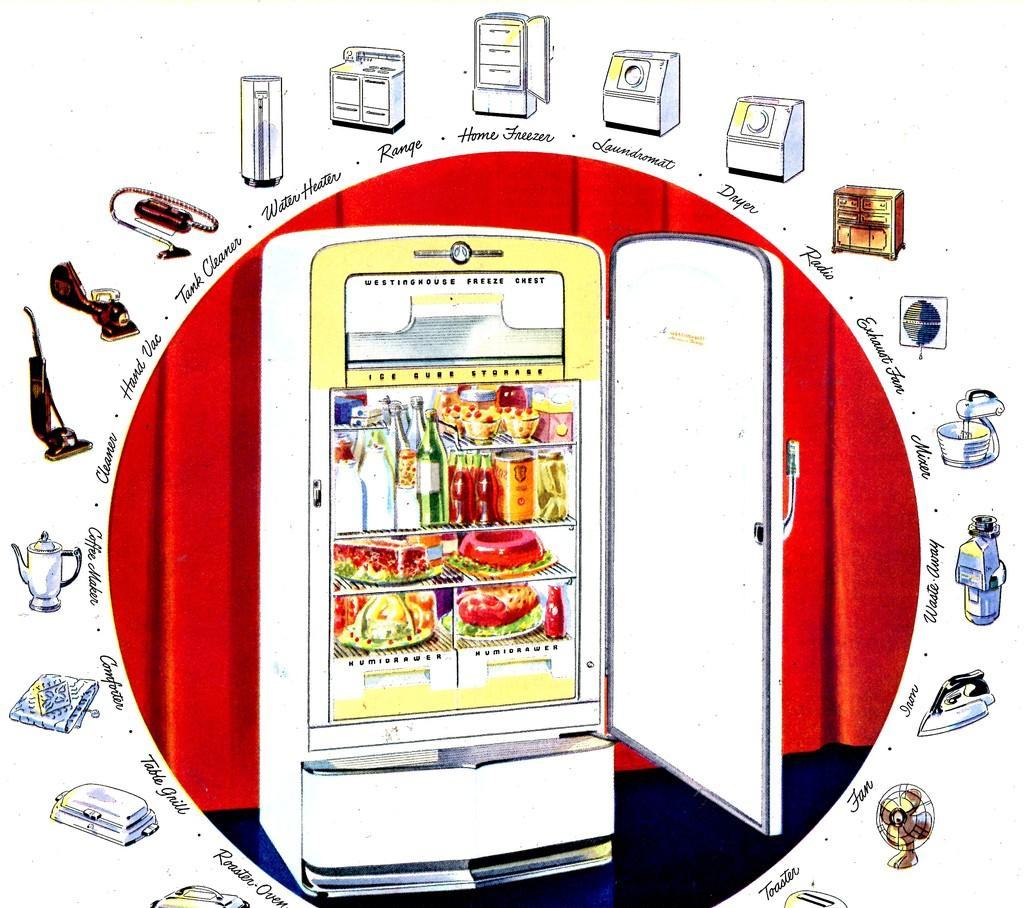<image>
Present a compact description of the photo's key features. an ad for Westinghouse freeze chest shows other appliances too 